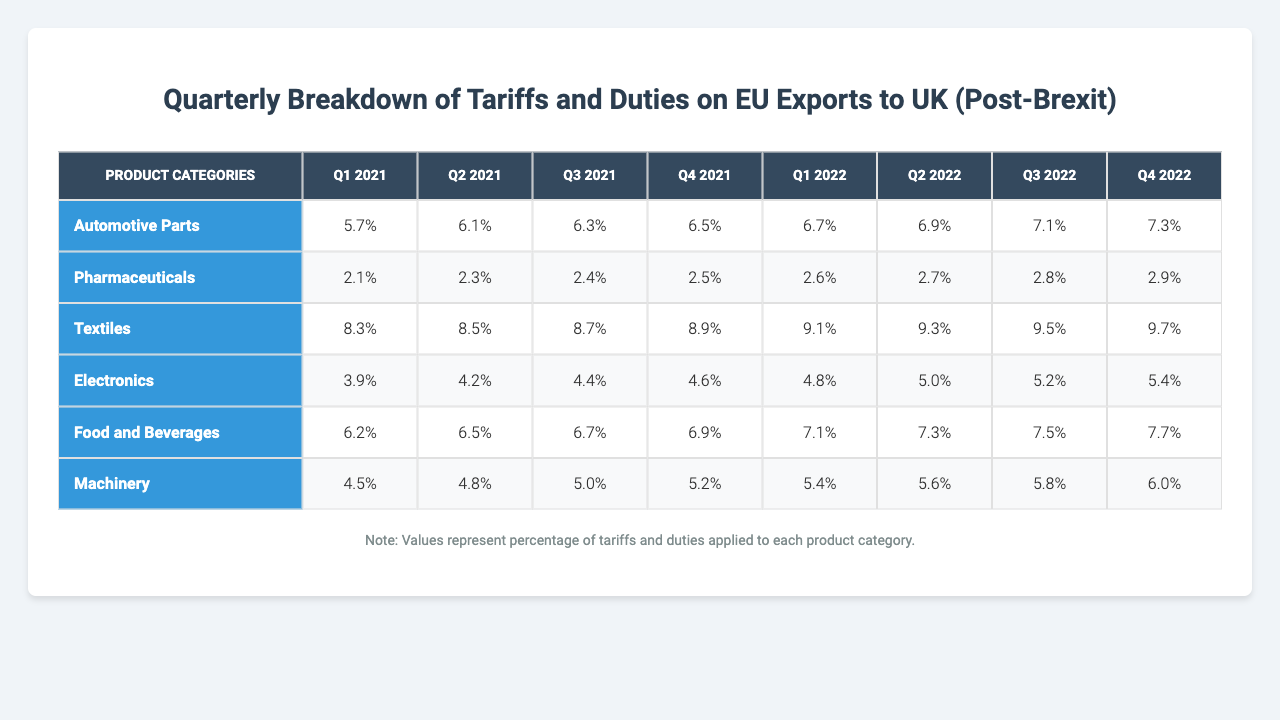What's the tariff percentage for Automotive Parts in Q2 2022? The table states that the tariff percentage for Automotive Parts in Q2 2022 is directly listed, which is 6.9%.
Answer: 6.9% What was the highest tariff percentage on Textiles observed in 2021? By examining the Textiles row across all quarters in 2021, we find the highest percentage in Q4 2021, which is 8.9%.
Answer: 8.9% Which product category had the lowest tariff in Q1 2021? The table shows that Pharmaceuticals had the lowest tariff percentage of 2.1% in Q1 2021 compared to the other categories.
Answer: 2.1% What is the average tariff percentage for Food and Beverages from Q1 2022 to Q4 2022? To calculate the average, we add the tariff percentages for Food and Beverages in each quarter: 7.1% + 7.3% + 7.5% + 7.7% = 29.6%. Then, dividing by the number of quarters (4) gives us 29.6% / 4 = 7.4%.
Answer: 7.4% Did the tariff on Machinery increase every quarter from Q1 2021 to Q4 2022? Reviewing the Machinery row shows that the percentage increased in Q1 through Q4 of every year observed (2021 and 2022). Hence, the tariff increased consistently.
Answer: Yes What is the difference in the tariff percentage of Electronics between Q1 2021 and Q4 2022? The tariff percentage for Electronics in Q1 2021 is 3.9% and in Q4 2022 is 5.4%. The difference is calculated as 5.4% - 3.9% = 1.5%.
Answer: 1.5% Which quarter had the highest overall tariff percentage for Pharmaceuticals? By looking at the Pharmaceuticals row, the highest tariff is in Q4 2022 at 2.9%.
Answer: Q4 2022 What product category showed a constant tariff percentage increase across all quarters listed? The trend is consistent for Automotive Parts, which has higher tariffs in each subsequent quarter throughout the table.
Answer: Automotive Parts What is the total of all tariffs applied to Textiles across Q1 2021 to Q4 2022? Adding the Textiles tariffs across all quarters gives us: 8.3% + 8.5% + 8.7% + 8.9% + 9.1% + 9.3% + 9.5% + 9.7% = 72.0%.
Answer: 72.0% Which product had the lowest percentage of tariffs in Q3 2022? In Q3 2022, looking at the percentages, the lowest is Pharmaceuticals with 2.8%.
Answer: 2.8% 